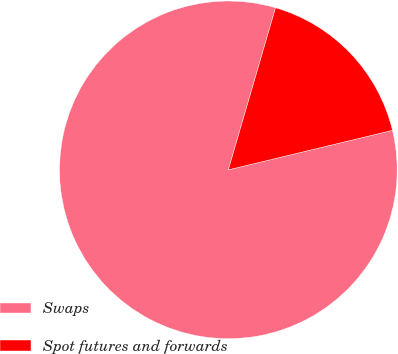Convert chart. <chart><loc_0><loc_0><loc_500><loc_500><pie_chart><fcel>Swaps<fcel>Spot futures and forwards<nl><fcel>83.27%<fcel>16.73%<nl></chart> 